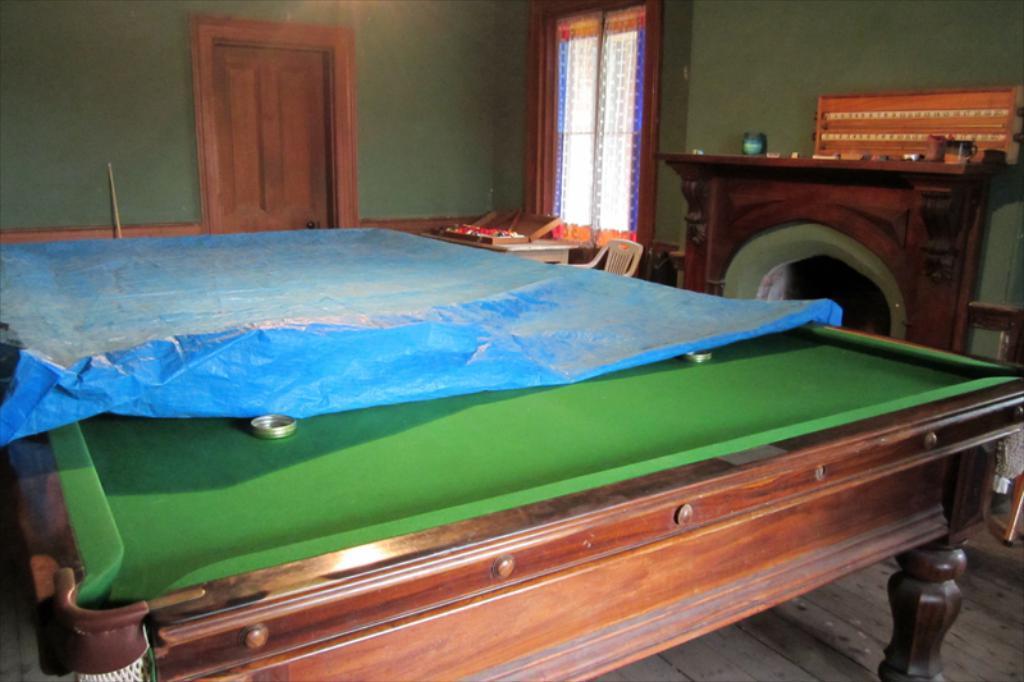Can you describe this image briefly? The picture is taken in a closed room where one billiard table is covered with sheet and at the right corner one fire place is present and table, chairs. Where one window is there behind the window one door and wall is present. 